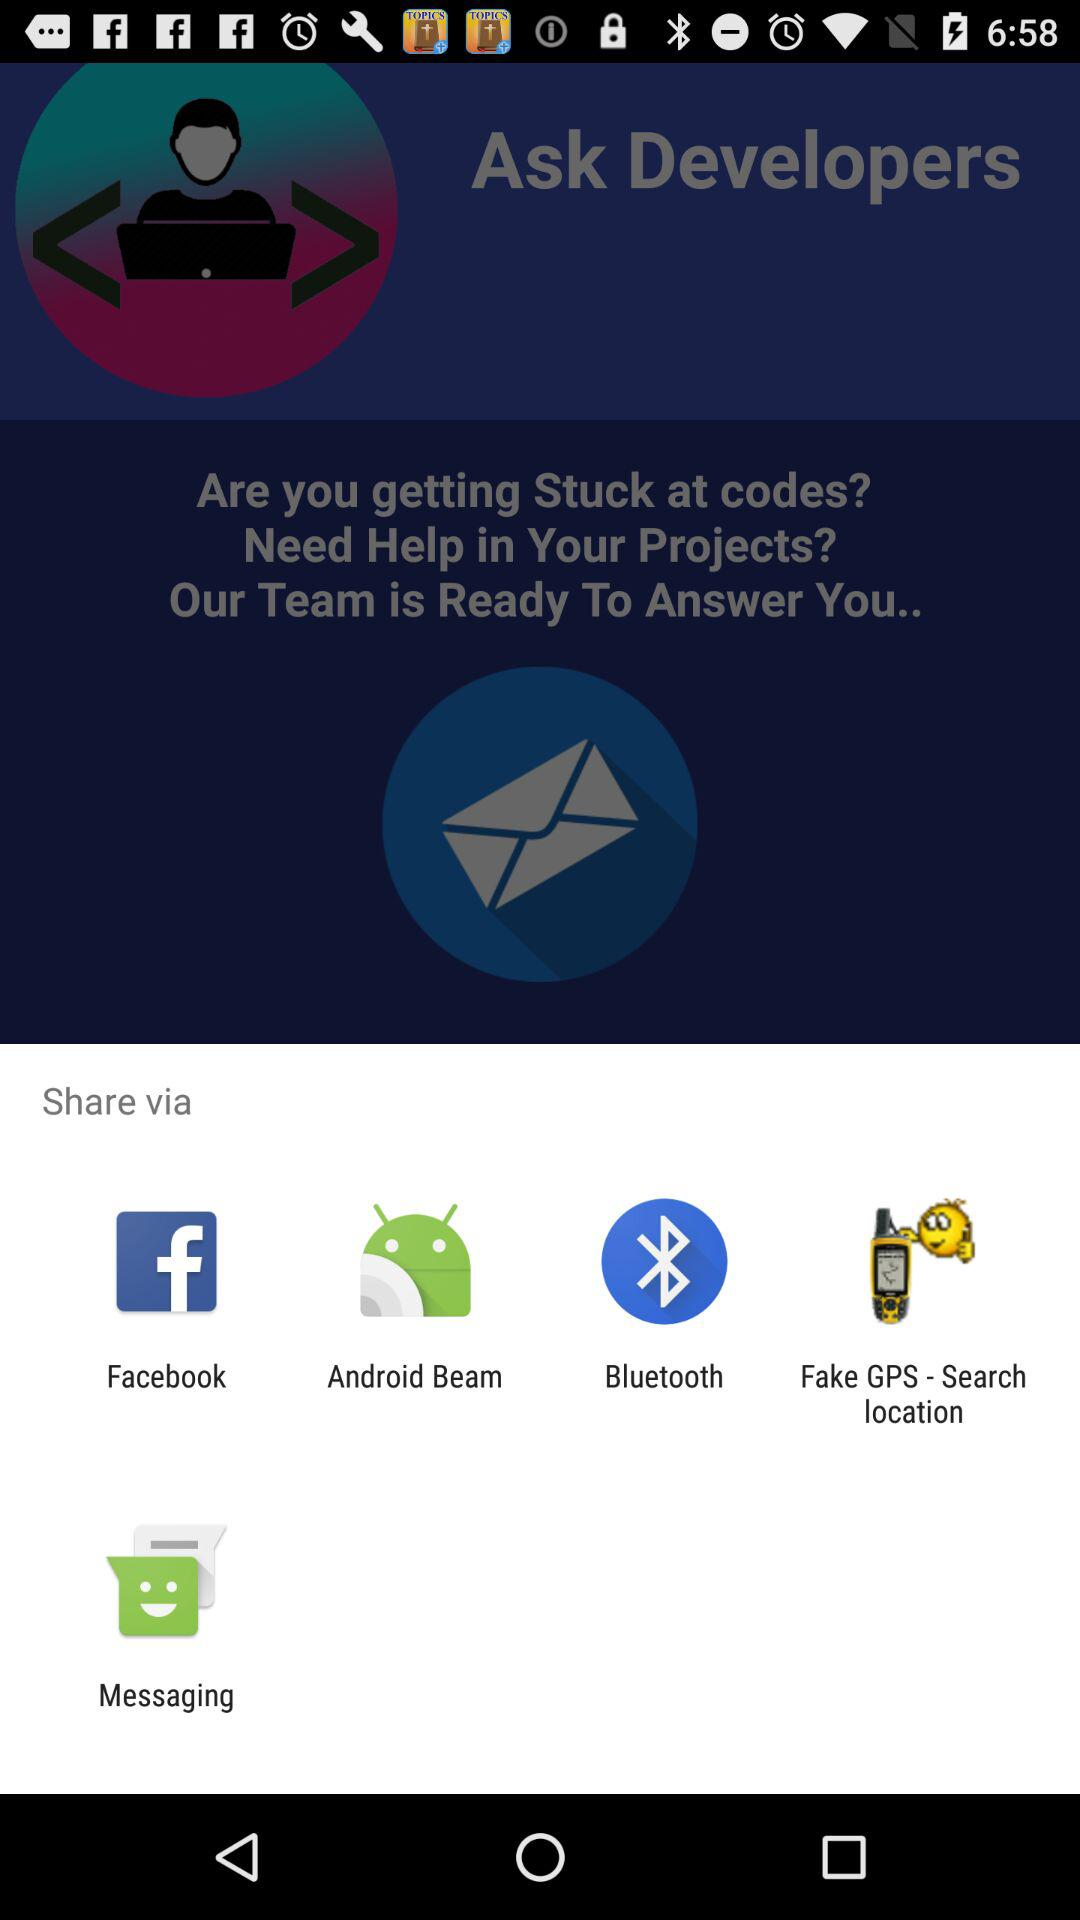What applications can be used to share? The applications that can be used to share are "Facebook", "Android Beam", "Bluetooth", "Fake GPS - Search location" and "Messaging". 